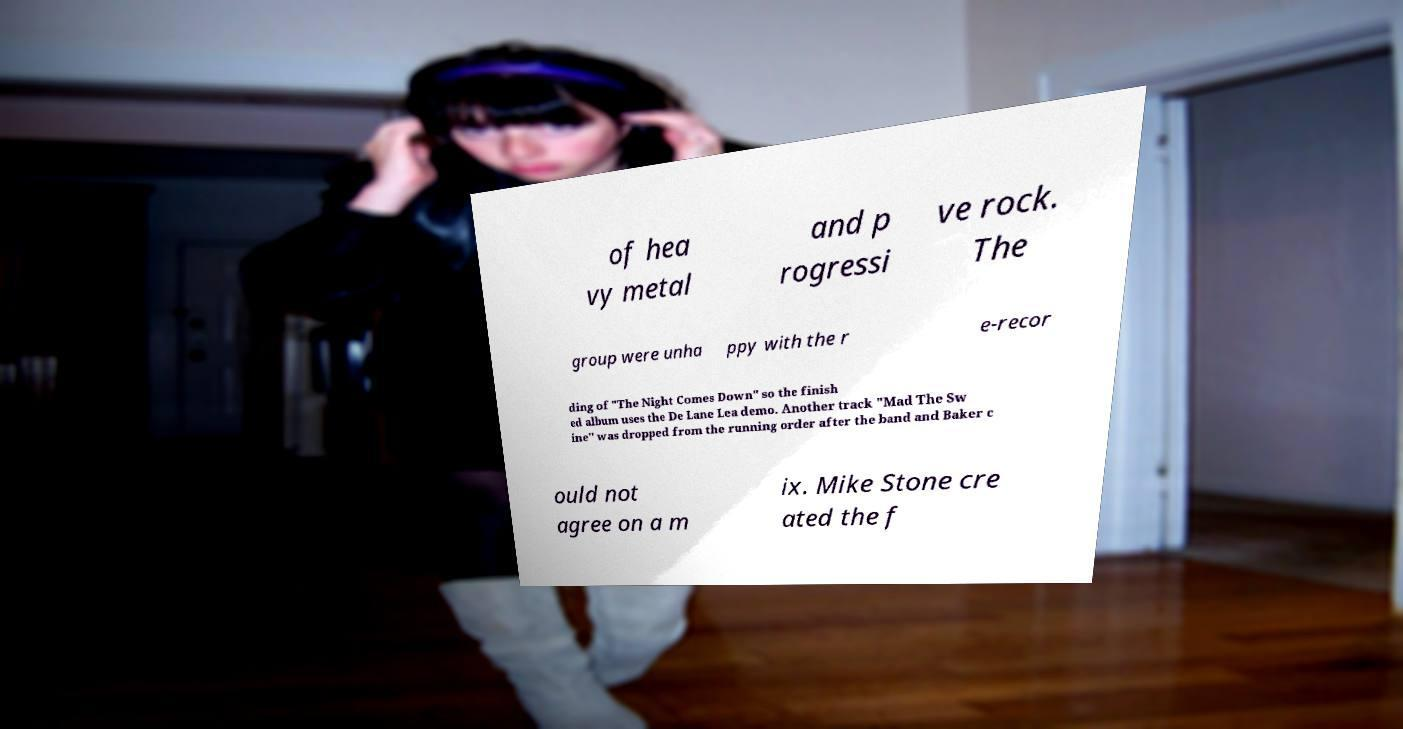I need the written content from this picture converted into text. Can you do that? of hea vy metal and p rogressi ve rock. The group were unha ppy with the r e-recor ding of "The Night Comes Down" so the finish ed album uses the De Lane Lea demo. Another track "Mad The Sw ine" was dropped from the running order after the band and Baker c ould not agree on a m ix. Mike Stone cre ated the f 